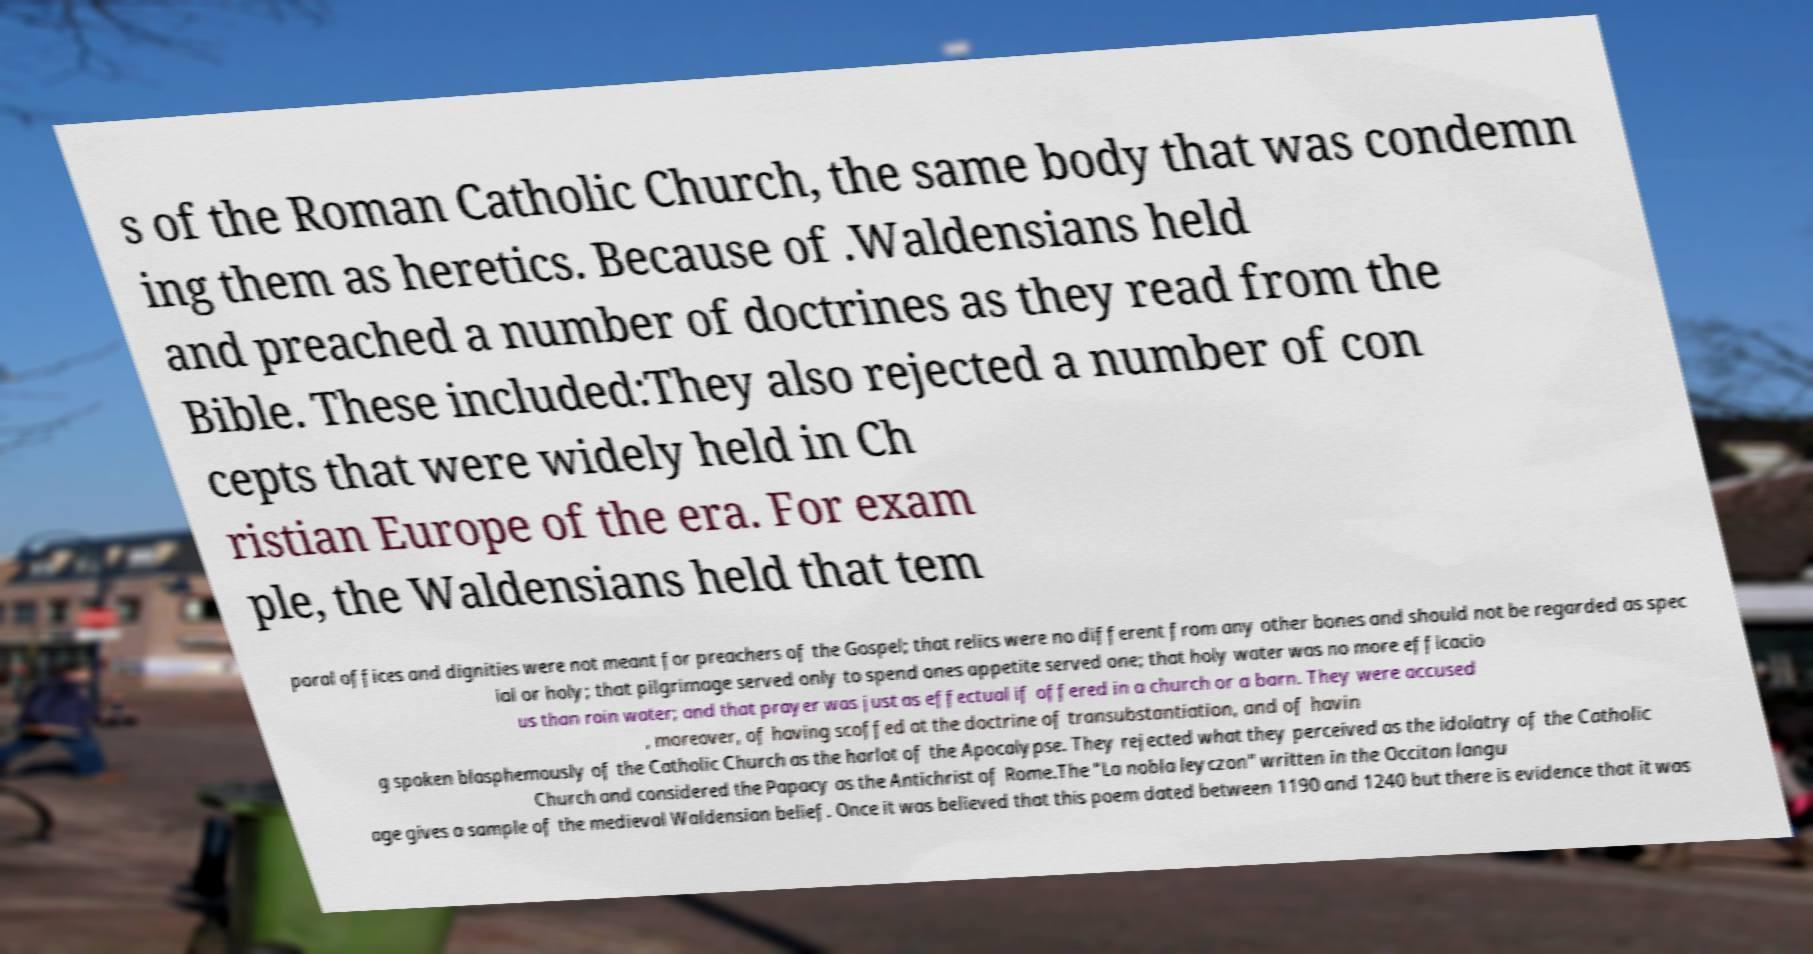Please read and relay the text visible in this image. What does it say? s of the Roman Catholic Church, the same body that was condemn ing them as heretics. Because of .Waldensians held and preached a number of doctrines as they read from the Bible. These included:They also rejected a number of con cepts that were widely held in Ch ristian Europe of the era. For exam ple, the Waldensians held that tem poral offices and dignities were not meant for preachers of the Gospel; that relics were no different from any other bones and should not be regarded as spec ial or holy; that pilgrimage served only to spend ones appetite served one; that holy water was no more efficacio us than rain water; and that prayer was just as effectual if offered in a church or a barn. They were accused , moreover, of having scoffed at the doctrine of transubstantiation, and of havin g spoken blasphemously of the Catholic Church as the harlot of the Apocalypse. They rejected what they perceived as the idolatry of the Catholic Church and considered the Papacy as the Antichrist of Rome.The "La nobla leyczon" written in the Occitan langu age gives a sample of the medieval Waldensian belief. Once it was believed that this poem dated between 1190 and 1240 but there is evidence that it was 